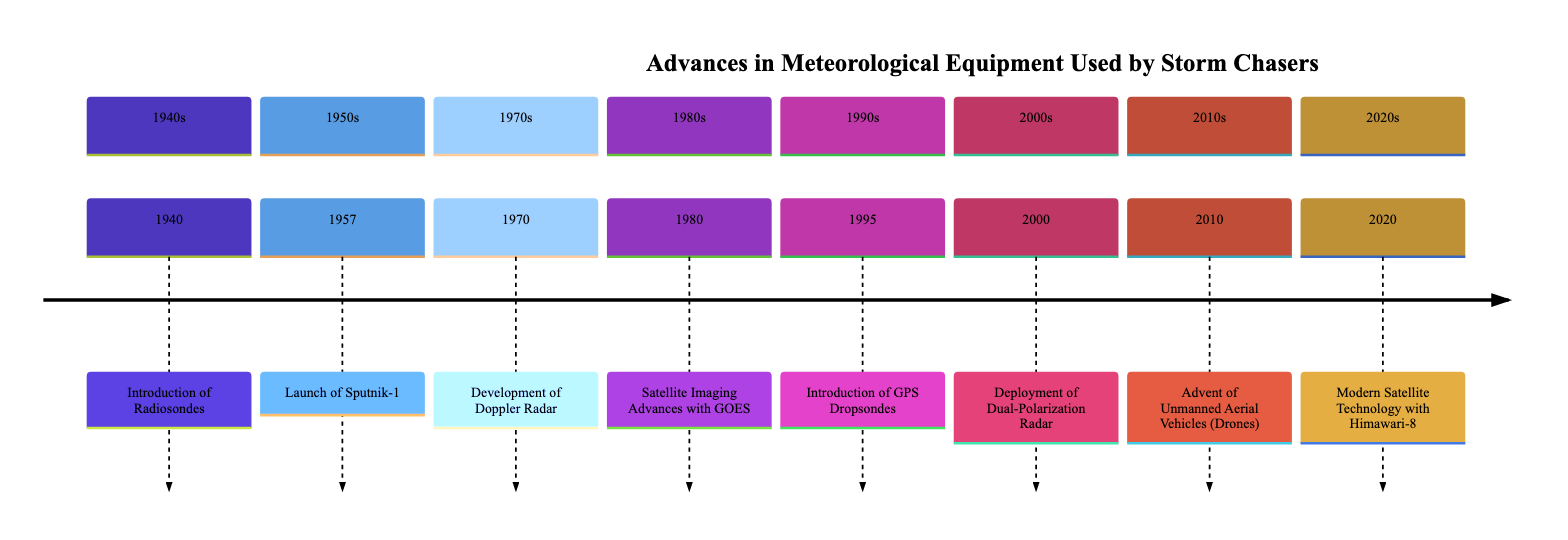What year did the introduction of radiosondes occur? The diagram indicates that the introduction of radiosondes took place in 1940, as shown in the first entry of the timeline.
Answer: 1940 What event happened in 1957? The timeline entry for 1957 specifies the launch of Sputnik-1, which is a key event in meteorological equipment advancements.
Answer: Launch of Sputnik-1 Which technology was introduced in 2010? According to the timeline, the technology introduced in 2010 is unmanned aerial vehicles (drones), which is stated in the corresponding section for that year.
Answer: Advent of Unmanned Aerial Vehicles (Drones) What was the notable development in the 1970s related to storm detection? The 1970 timeline entry highlights the development of Doppler radar, which significantly improved the detection of storm systems, particularly in terms of rotational movements.
Answer: Development of Doppler Radar How many advancements in meteorological equipment are listed from the 1980s onward? In examining the timeline sections from the 1980s onward, there are a total of four advancements detailed: Satellite Imaging Advances with GOES (1980), Introduction of GPS Dropsondes (1995), Deployment of Dual-Polarization Radar (2000), and the Advent of Unmanned Aerial Vehicles (2010).
Answer: 4 What significant feature did the Himawari-8 satellite provide after its launch in 2020? The diagram states that the Himawari-8 satellite provided high-frequency, detailed images which greatly enhanced short-term weather forecasting after its launch.
Answer: High-frequency, detailed images Which meteorological advancement was responsible for improving precipitation estimates? The deployment of dual-polarization radar in 2000, as noted in the timeline, is specified as being responsible for providing detailed information on precipitation types, hence improving precipitation estimates.
Answer: Deployment of Dual-Polarization Radar Which advancement allows for real-time storm monitoring from space? The timeline indicates that the Geostationary Operational Environmental Satellite (GOES), introduced in 1980, allows for real-time monitoring of storm development from space.
Answer: Satellite Imaging Advances with GOES What atmospheric data was obtained from GPS dropsondes introduced in 1995? The timeline describes GPS dropsondes as instruments that measure atmospheric parameters when dropped into storms, thus providing crucial data for hurricane intensity forecasts, which is the specific atmospheric data they provided.
Answer: Hurricane intensity forecasts 